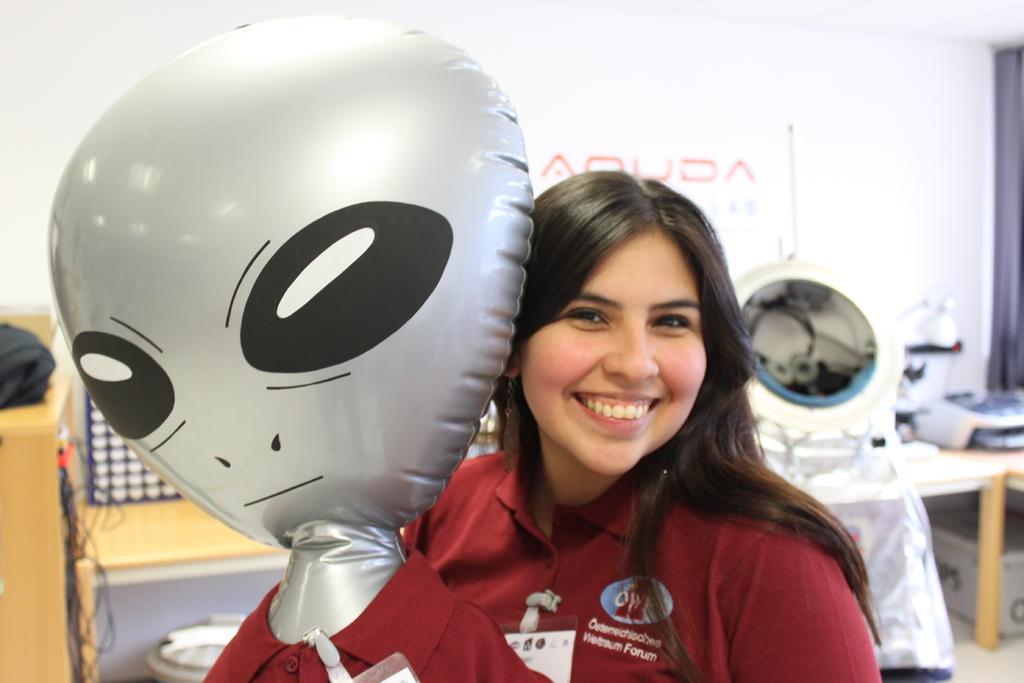In one or two sentences, can you explain what this image depicts? In this image we can see a woman wearing maroon color T-shirt is smiling and holding an alien air balloon with maroon T-shirt and identity card. The background of the image is slightly blurred, where we can see wooden table, wires, a few things here and the banner. 